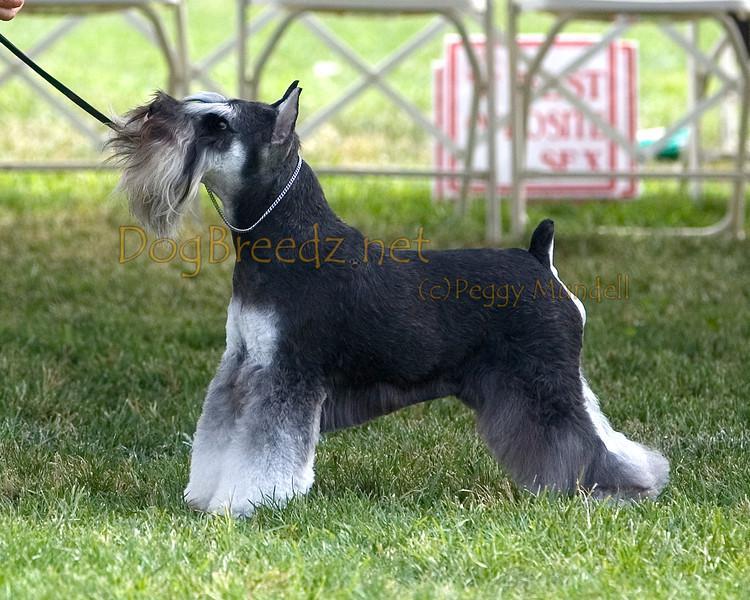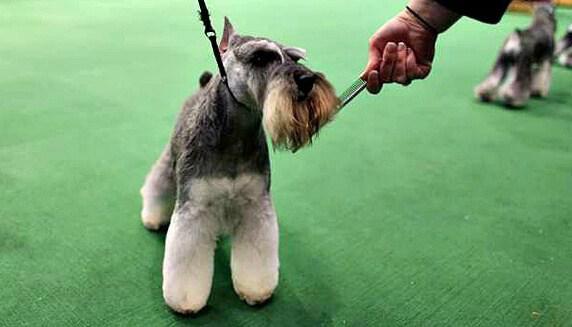The first image is the image on the left, the second image is the image on the right. For the images shown, is this caption "The dog in the image on the right is standing up on all four." true? Answer yes or no. Yes. The first image is the image on the left, the second image is the image on the right. For the images displayed, is the sentence "A schnauzer on a leash is in profile facing leftward in front of some type of white lattice." factually correct? Answer yes or no. Yes. 